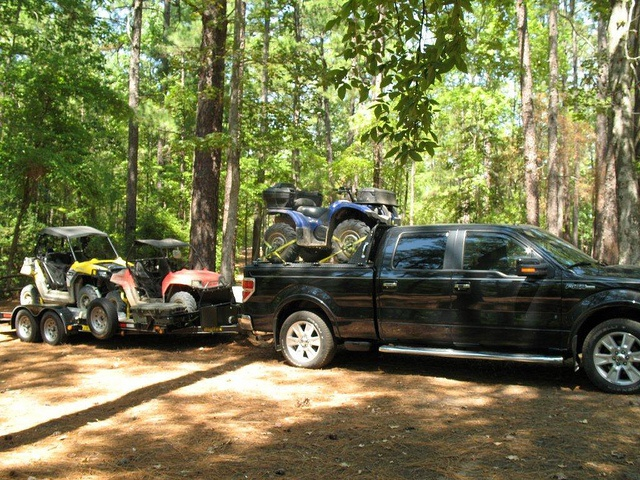Describe the objects in this image and their specific colors. I can see truck in darkgreen, black, gray, darkgray, and purple tones, truck in darkgreen, black, gray, and beige tones, and truck in darkgreen, gray, black, and darkgray tones in this image. 